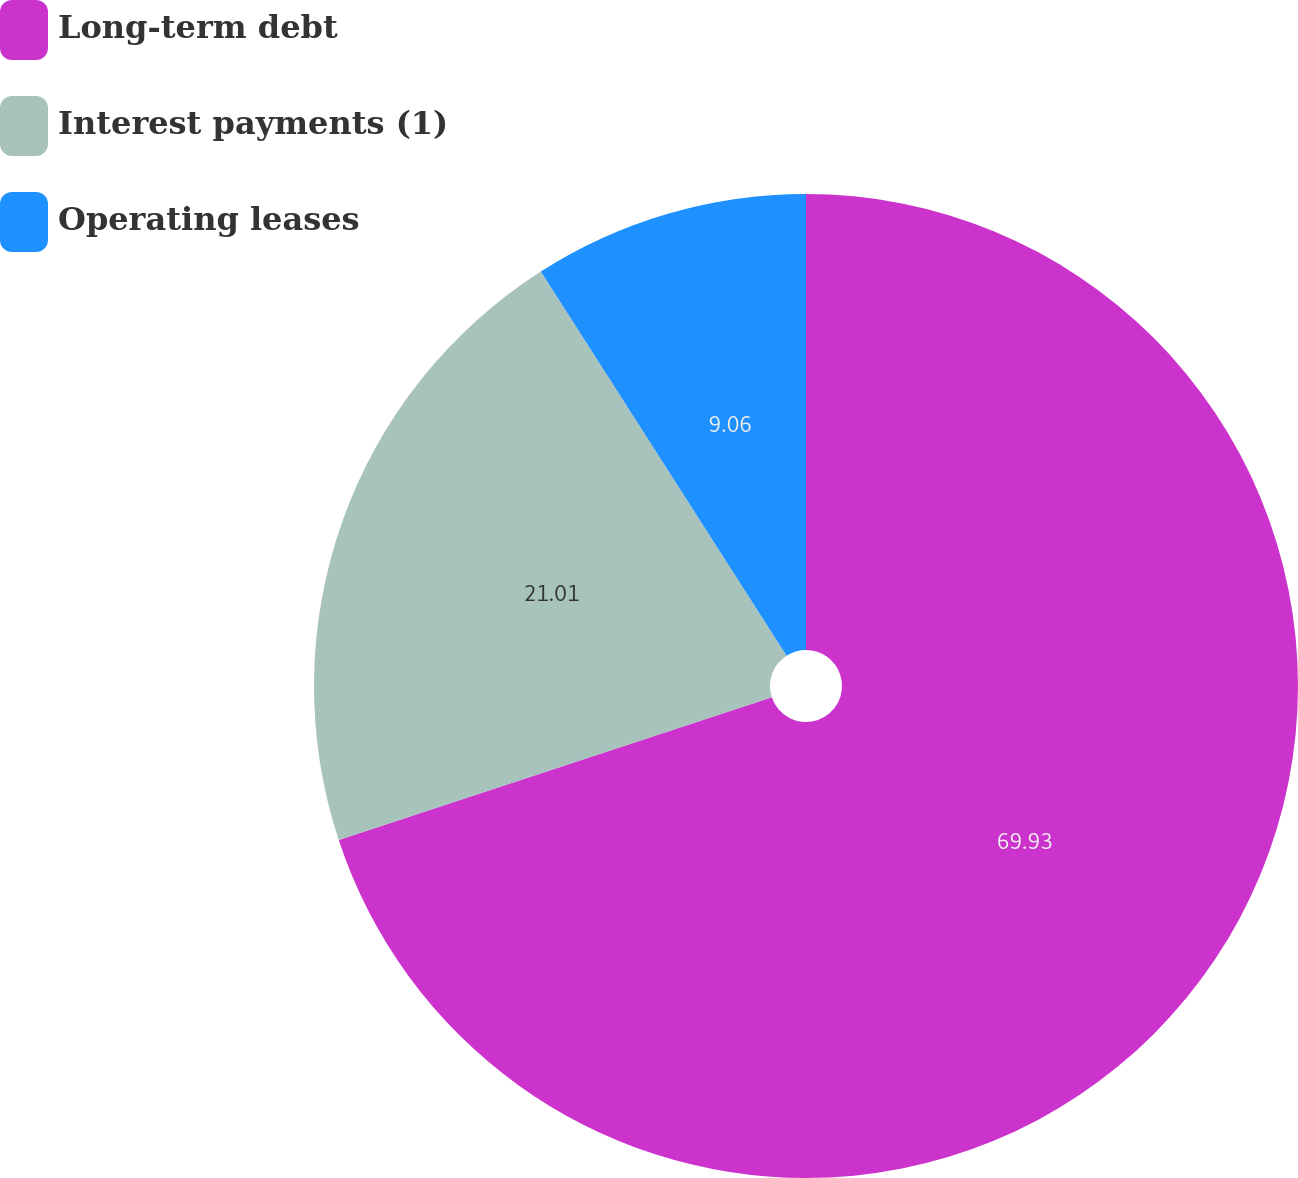Convert chart to OTSL. <chart><loc_0><loc_0><loc_500><loc_500><pie_chart><fcel>Long-term debt<fcel>Interest payments (1)<fcel>Operating leases<nl><fcel>69.94%<fcel>21.01%<fcel>9.06%<nl></chart> 